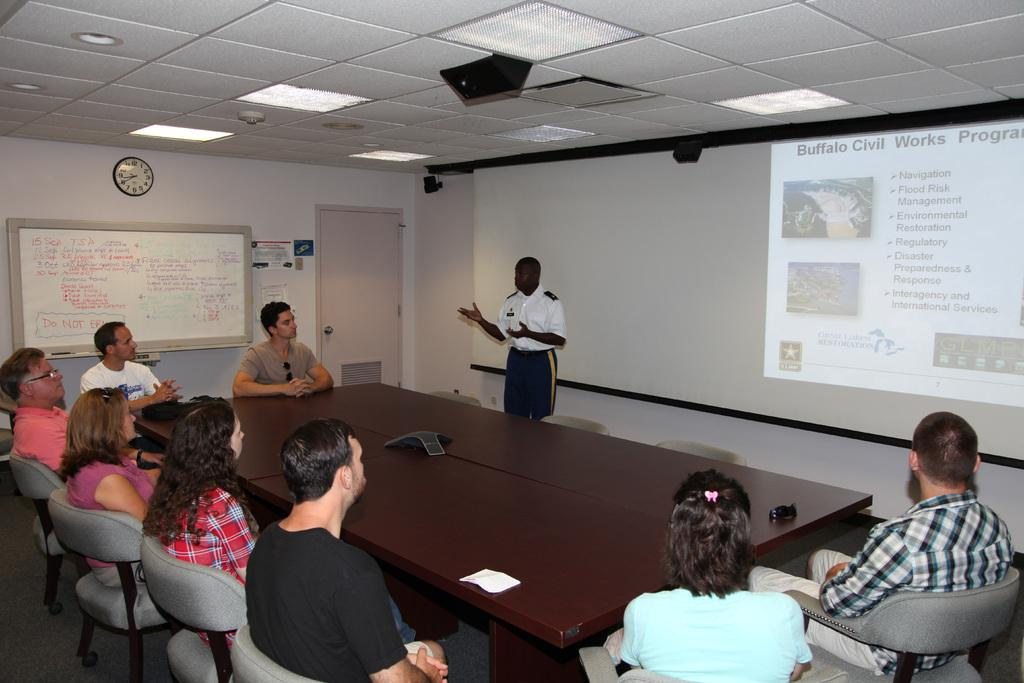What is present in the room that can be used for writing or displaying information? There is a whiteboard in the room. What is another item in the room that can be used for displaying information? There is a projector screen in the room. How are the people in the room positioned? The people are sitting around a table, and they are sitting in chairs. Can you describe the standing person in the room? There is a person standing in the room, but no specific details about their appearance or actions are provided. What type of ocean can be seen through the window in the room? There is no window or ocean present in the room; the image only shows a whiteboard, projector screen, a group of people sitting around a table, and a person standing. 